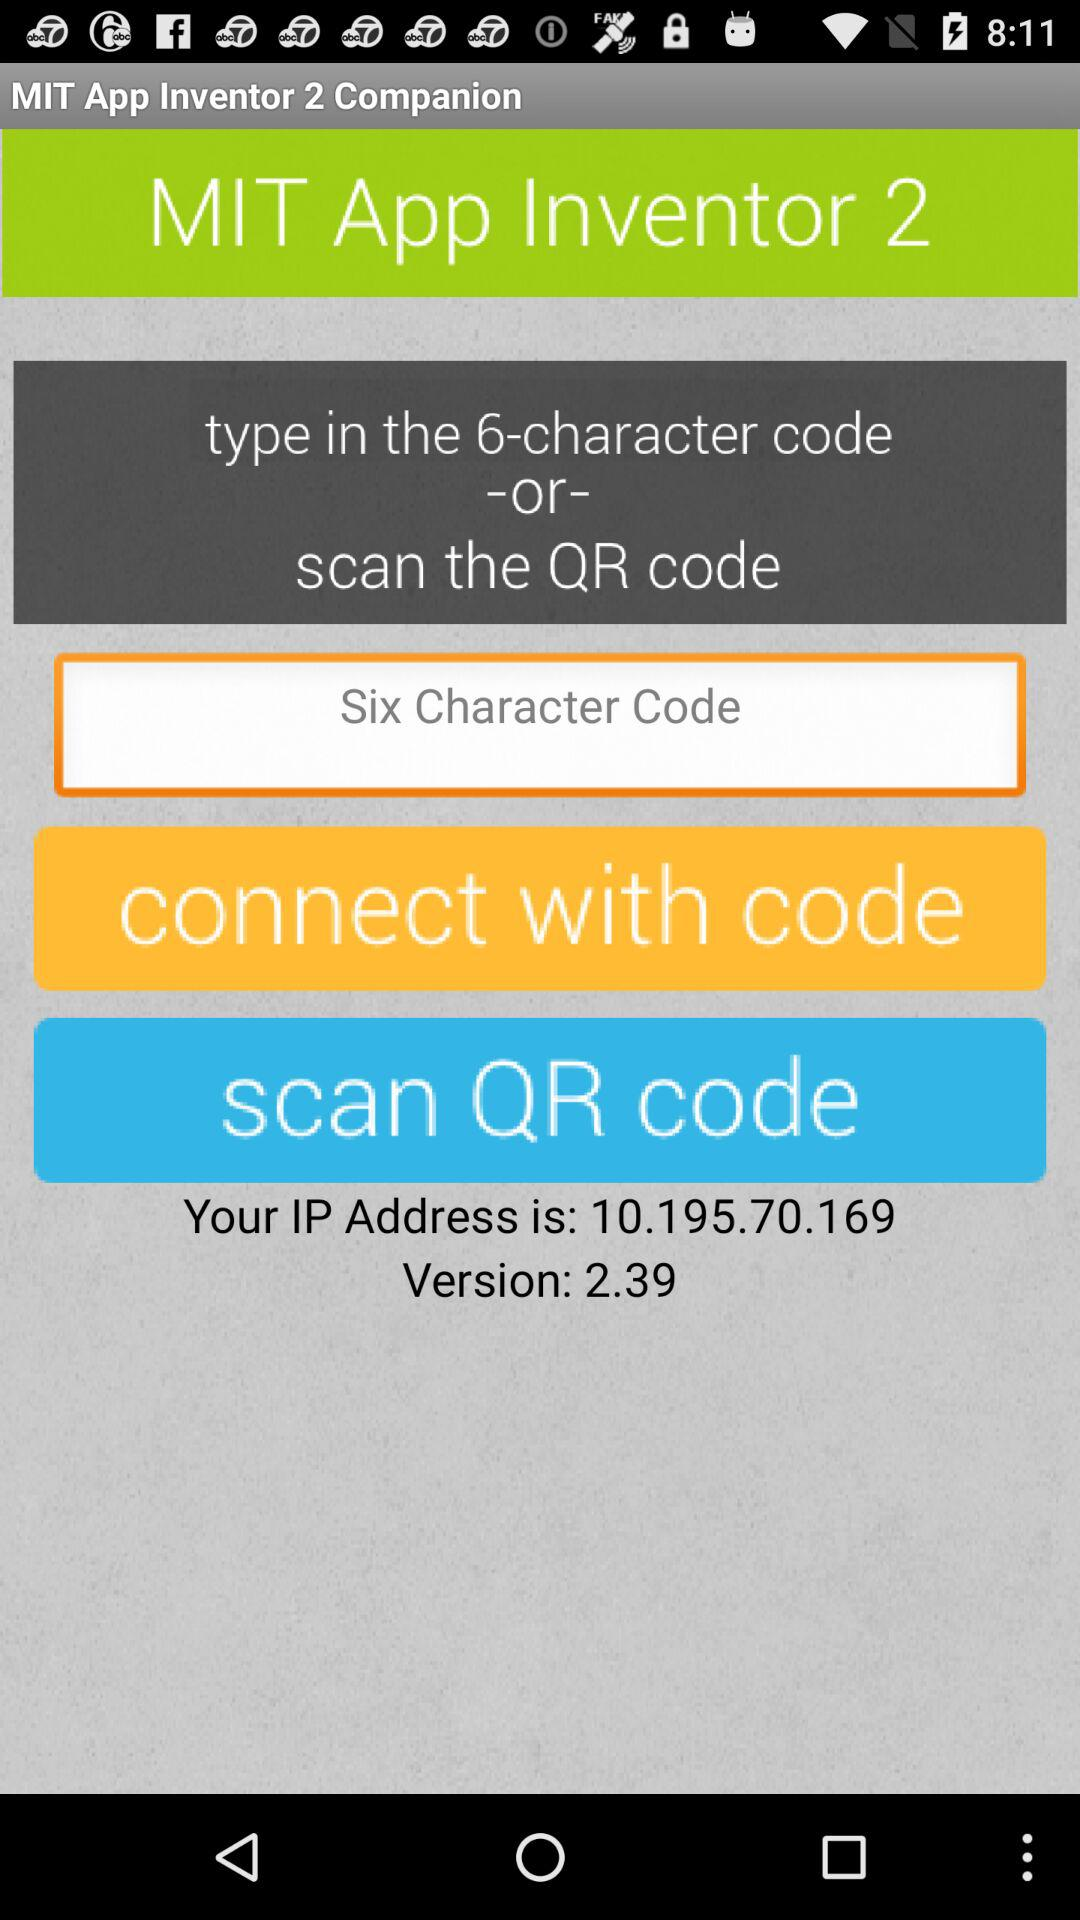What is the name of the application? The name of the application is "MIT App Inventor 2 Companion". 